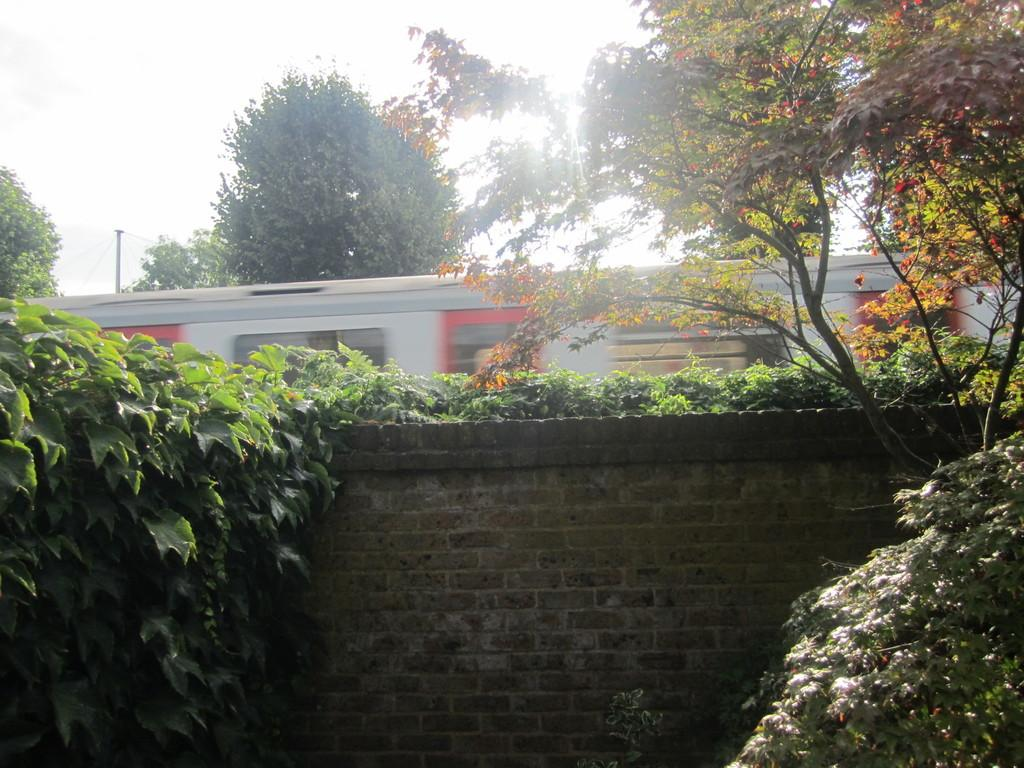What is the main subject of the image? There is a train in the image. Where is the train located? The train is on a track. What type of vegetation can be seen in the image? There are trees and plants in the image. How many geese are sitting on the bed in the image? There is no bed or geese present in the image. What type of ant can be seen crawling on the train in the image? There are no ants visible in the image, and the train is not being crawled on by any insects. 